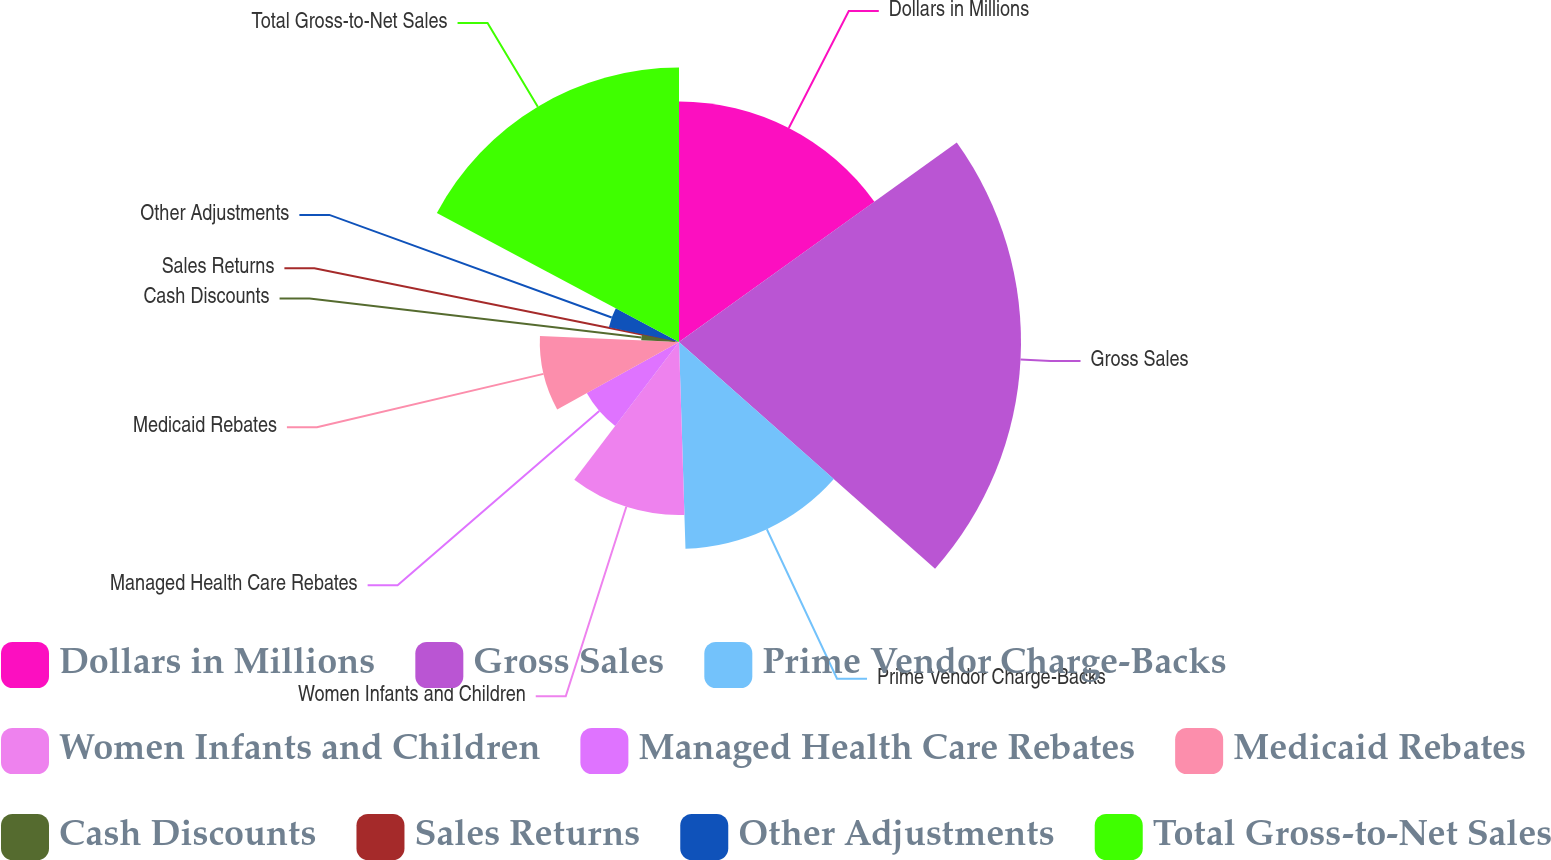Convert chart. <chart><loc_0><loc_0><loc_500><loc_500><pie_chart><fcel>Dollars in Millions<fcel>Gross Sales<fcel>Prime Vendor Charge-Backs<fcel>Women Infants and Children<fcel>Managed Health Care Rebates<fcel>Medicaid Rebates<fcel>Cash Discounts<fcel>Sales Returns<fcel>Other Adjustments<fcel>Total Gross-to-Net Sales<nl><fcel>15.09%<fcel>21.45%<fcel>12.97%<fcel>10.85%<fcel>6.61%<fcel>8.73%<fcel>2.37%<fcel>0.25%<fcel>4.49%<fcel>17.21%<nl></chart> 